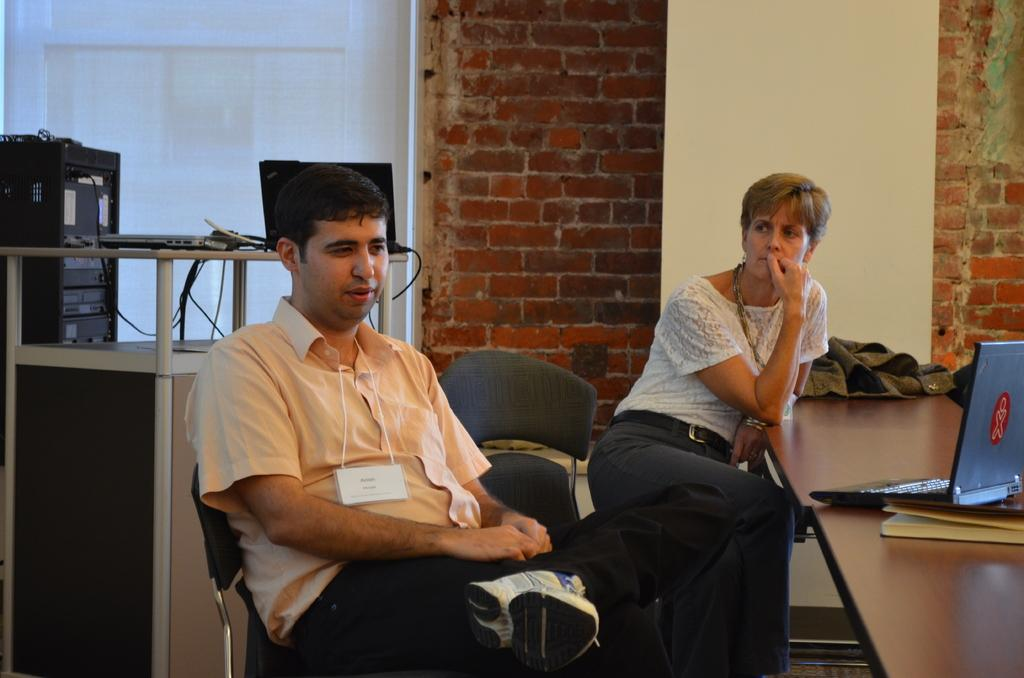How many people are sitting in the image? There are two persons sitting on chairs in the image. What objects are on the table? There is a laptop, a book, and cloth on the table. What can be seen in the background of the image? There is a wall and a board in the background. Is there another laptop visible in the image? Yes, there is a laptop visible in the background. What is the chance of hearing a sponge in the image? There is no mention of a sponge in the image, and therefore it cannot be heard or seen. 